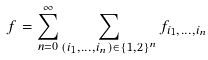<formula> <loc_0><loc_0><loc_500><loc_500>f = \sum _ { n = 0 } ^ { \infty } \sum _ { ( i _ { 1 } , \dots , i _ { n } ) \in \{ 1 , 2 \} ^ { n } } f _ { i _ { 1 } , \dots , i _ { n } }</formula> 